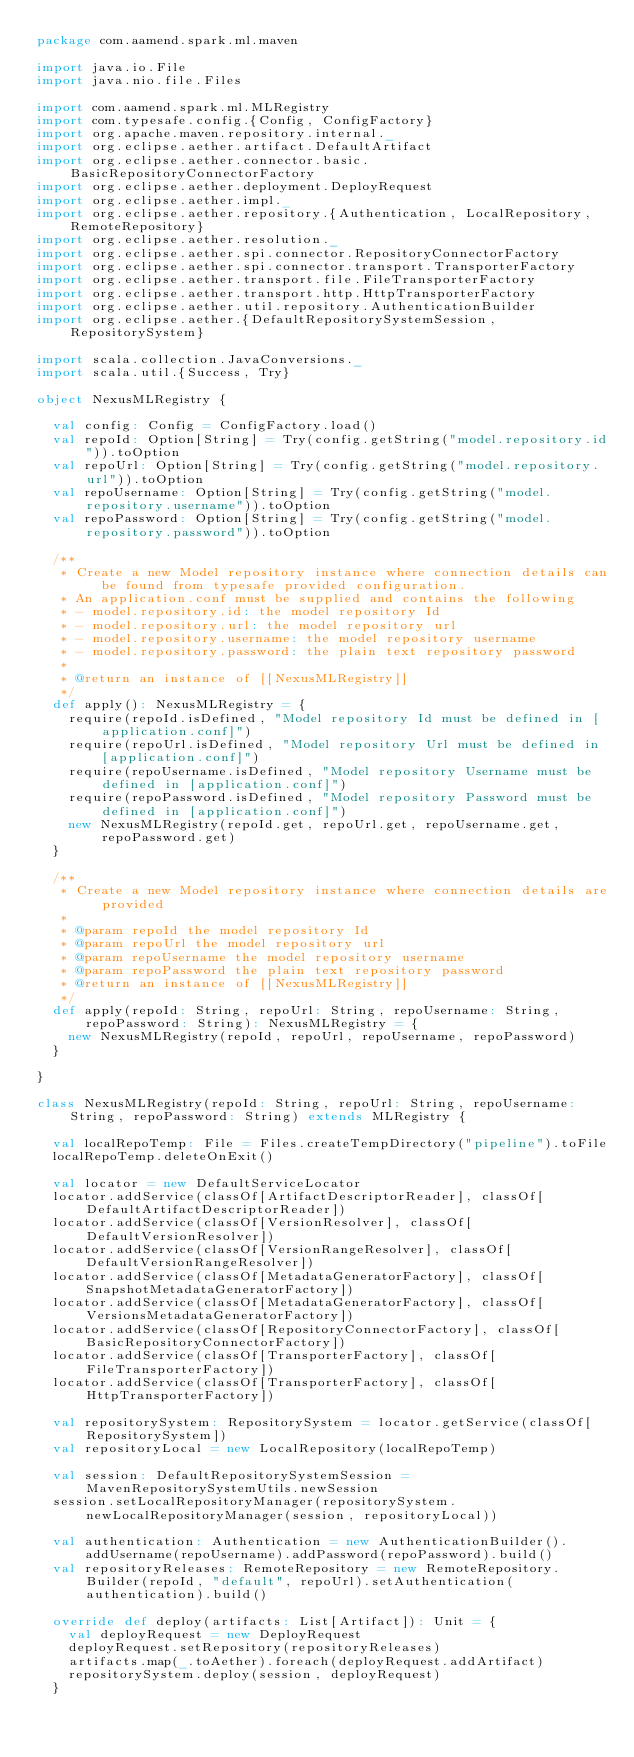Convert code to text. <code><loc_0><loc_0><loc_500><loc_500><_Scala_>package com.aamend.spark.ml.maven

import java.io.File
import java.nio.file.Files

import com.aamend.spark.ml.MLRegistry
import com.typesafe.config.{Config, ConfigFactory}
import org.apache.maven.repository.internal._
import org.eclipse.aether.artifact.DefaultArtifact
import org.eclipse.aether.connector.basic.BasicRepositoryConnectorFactory
import org.eclipse.aether.deployment.DeployRequest
import org.eclipse.aether.impl._
import org.eclipse.aether.repository.{Authentication, LocalRepository, RemoteRepository}
import org.eclipse.aether.resolution._
import org.eclipse.aether.spi.connector.RepositoryConnectorFactory
import org.eclipse.aether.spi.connector.transport.TransporterFactory
import org.eclipse.aether.transport.file.FileTransporterFactory
import org.eclipse.aether.transport.http.HttpTransporterFactory
import org.eclipse.aether.util.repository.AuthenticationBuilder
import org.eclipse.aether.{DefaultRepositorySystemSession, RepositorySystem}

import scala.collection.JavaConversions._
import scala.util.{Success, Try}

object NexusMLRegistry {

  val config: Config = ConfigFactory.load()
  val repoId: Option[String] = Try(config.getString("model.repository.id")).toOption
  val repoUrl: Option[String] = Try(config.getString("model.repository.url")).toOption
  val repoUsername: Option[String] = Try(config.getString("model.repository.username")).toOption
  val repoPassword: Option[String] = Try(config.getString("model.repository.password")).toOption

  /**
   * Create a new Model repository instance where connection details can be found from typesafe provided configuration.
   * An application.conf must be supplied and contains the following
   * - model.repository.id: the model repository Id
   * - model.repository.url: the model repository url
   * - model.repository.username: the model repository username
   * - model.repository.password: the plain text repository password
   *
   * @return an instance of [[NexusMLRegistry]]
   */
  def apply(): NexusMLRegistry = {
    require(repoId.isDefined, "Model repository Id must be defined in [application.conf]")
    require(repoUrl.isDefined, "Model repository Url must be defined in [application.conf]")
    require(repoUsername.isDefined, "Model repository Username must be defined in [application.conf]")
    require(repoPassword.isDefined, "Model repository Password must be defined in [application.conf]")
    new NexusMLRegistry(repoId.get, repoUrl.get, repoUsername.get, repoPassword.get)
  }

  /**
   * Create a new Model repository instance where connection details are provided
   *
   * @param repoId the model repository Id
   * @param repoUrl the model repository url
   * @param repoUsername the model repository username
   * @param repoPassword the plain text repository password
   * @return an instance of [[NexusMLRegistry]]
   */
  def apply(repoId: String, repoUrl: String, repoUsername: String, repoPassword: String): NexusMLRegistry = {
    new NexusMLRegistry(repoId, repoUrl, repoUsername, repoPassword)
  }

}

class NexusMLRegistry(repoId: String, repoUrl: String, repoUsername: String, repoPassword: String) extends MLRegistry {

  val localRepoTemp: File = Files.createTempDirectory("pipeline").toFile
  localRepoTemp.deleteOnExit()

  val locator = new DefaultServiceLocator
  locator.addService(classOf[ArtifactDescriptorReader], classOf[DefaultArtifactDescriptorReader])
  locator.addService(classOf[VersionResolver], classOf[DefaultVersionResolver])
  locator.addService(classOf[VersionRangeResolver], classOf[DefaultVersionRangeResolver])
  locator.addService(classOf[MetadataGeneratorFactory], classOf[SnapshotMetadataGeneratorFactory])
  locator.addService(classOf[MetadataGeneratorFactory], classOf[VersionsMetadataGeneratorFactory])
  locator.addService(classOf[RepositoryConnectorFactory], classOf[BasicRepositoryConnectorFactory])
  locator.addService(classOf[TransporterFactory], classOf[FileTransporterFactory])
  locator.addService(classOf[TransporterFactory], classOf[HttpTransporterFactory])

  val repositorySystem: RepositorySystem = locator.getService(classOf[RepositorySystem])
  val repositoryLocal = new LocalRepository(localRepoTemp)

  val session: DefaultRepositorySystemSession = MavenRepositorySystemUtils.newSession
  session.setLocalRepositoryManager(repositorySystem.newLocalRepositoryManager(session, repositoryLocal))

  val authentication: Authentication = new AuthenticationBuilder().addUsername(repoUsername).addPassword(repoPassword).build()
  val repositoryReleases: RemoteRepository = new RemoteRepository.Builder(repoId, "default", repoUrl).setAuthentication(authentication).build()

  override def deploy(artifacts: List[Artifact]): Unit = {
    val deployRequest = new DeployRequest
    deployRequest.setRepository(repositoryReleases)
    artifacts.map(_.toAether).foreach(deployRequest.addArtifact)
    repositorySystem.deploy(session, deployRequest)
  }
</code> 